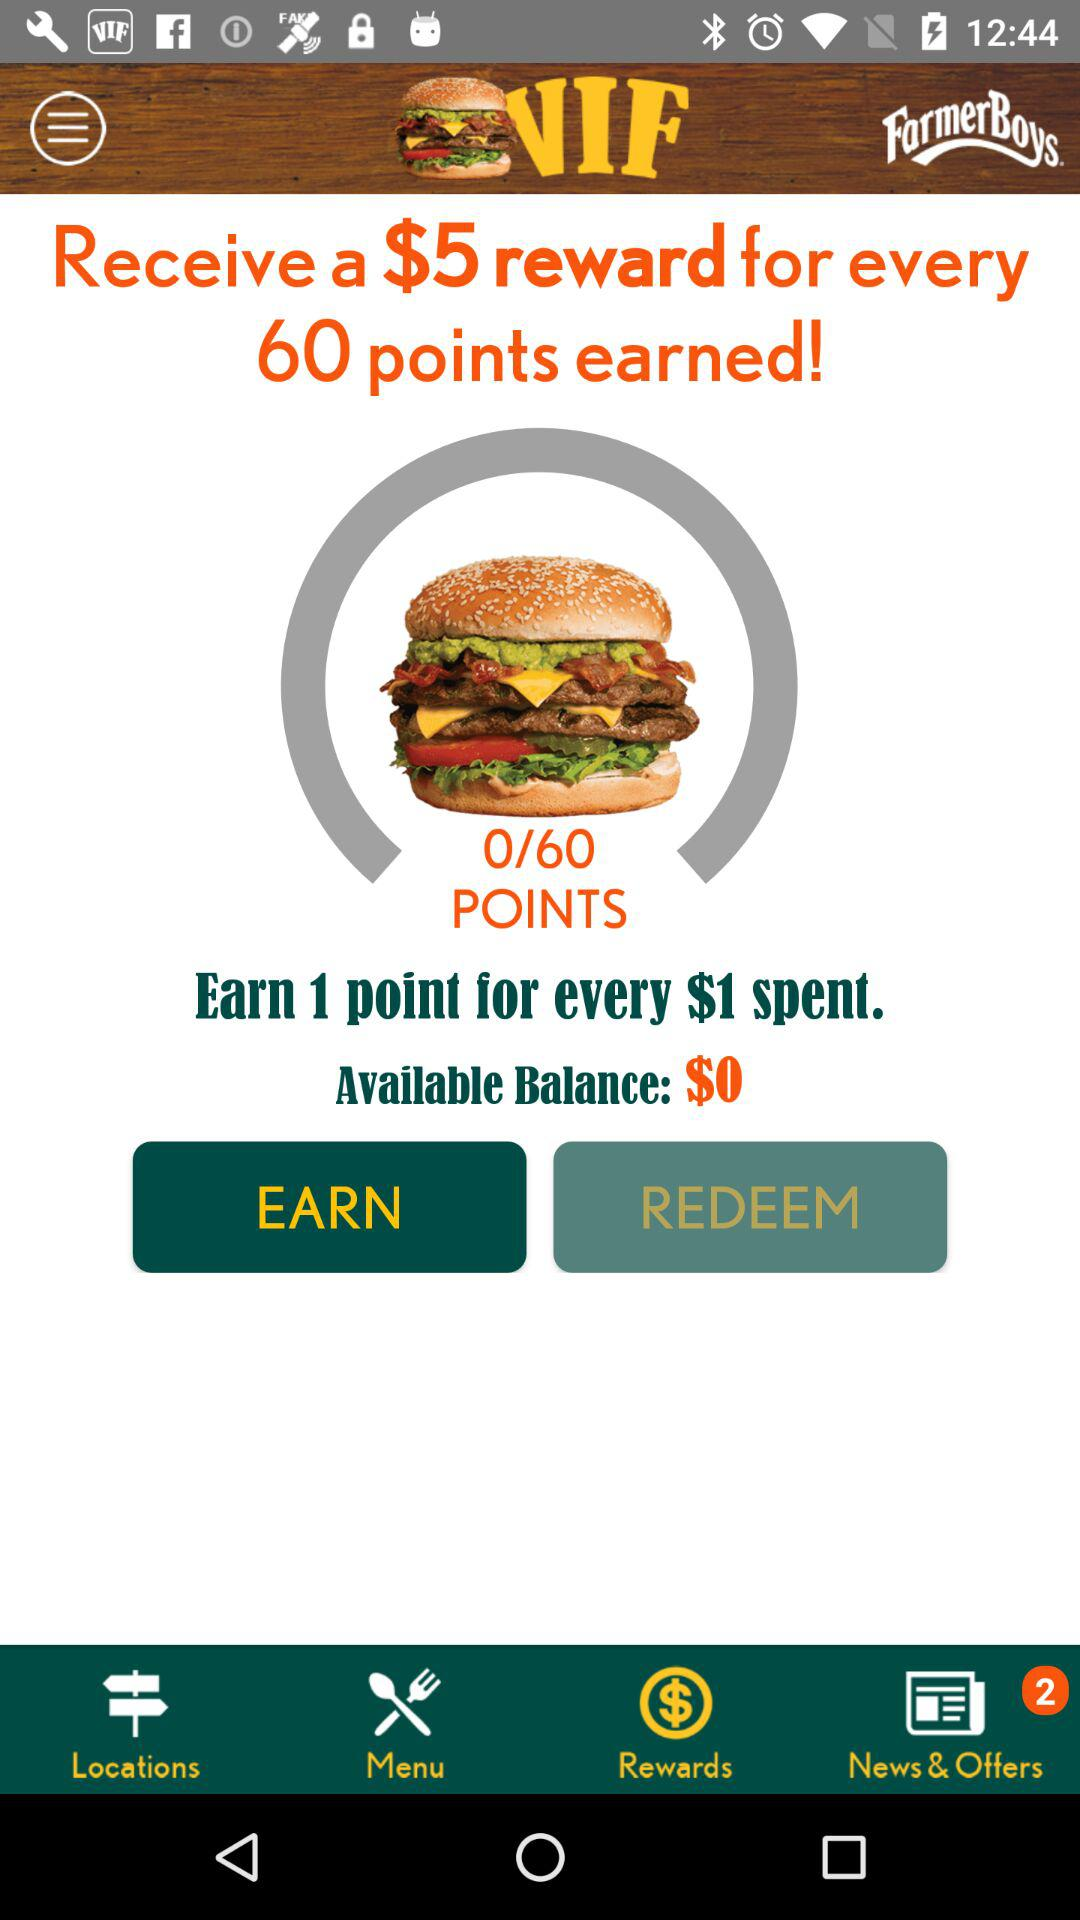What is the total available balance? The total available balance is $0. 